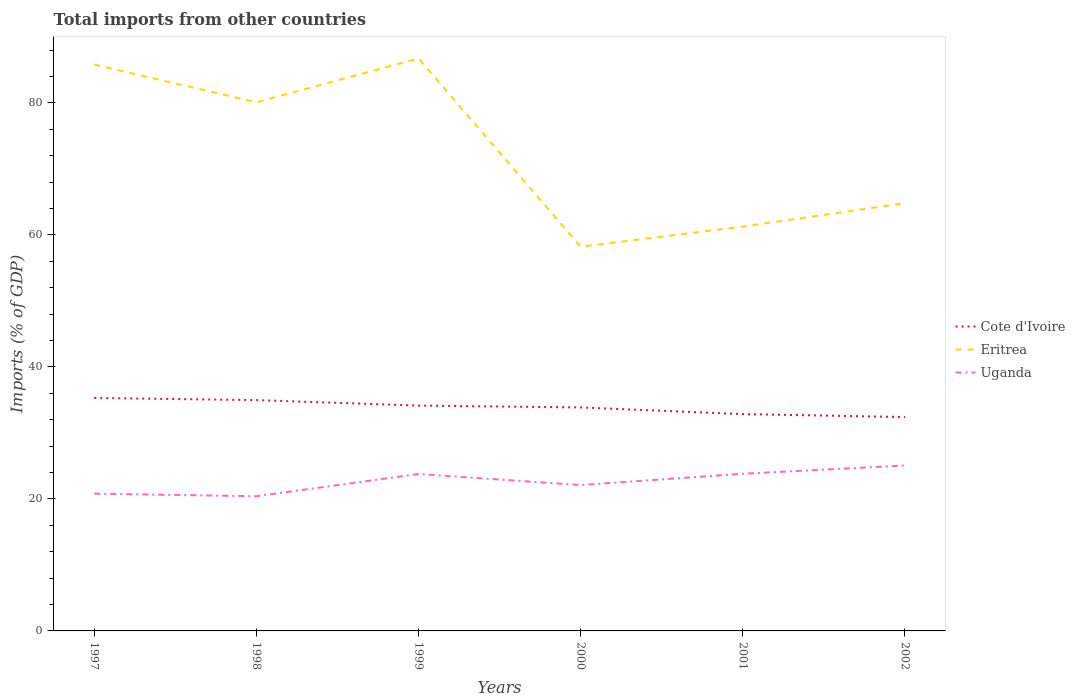How many different coloured lines are there?
Your answer should be compact. 3. Does the line corresponding to Eritrea intersect with the line corresponding to Uganda?
Ensure brevity in your answer.  No. Across all years, what is the maximum total imports in Uganda?
Ensure brevity in your answer.  20.4. In which year was the total imports in Cote d'Ivoire maximum?
Your response must be concise. 2002. What is the total total imports in Uganda in the graph?
Offer a very short reply. -1.29. What is the difference between the highest and the second highest total imports in Eritrea?
Provide a succinct answer. 28.51. What is the difference between the highest and the lowest total imports in Uganda?
Provide a short and direct response. 3. What is the difference between two consecutive major ticks on the Y-axis?
Keep it short and to the point. 20. Does the graph contain any zero values?
Make the answer very short. No. Does the graph contain grids?
Provide a short and direct response. No. Where does the legend appear in the graph?
Offer a terse response. Center right. How are the legend labels stacked?
Keep it short and to the point. Vertical. What is the title of the graph?
Provide a succinct answer. Total imports from other countries. What is the label or title of the X-axis?
Keep it short and to the point. Years. What is the label or title of the Y-axis?
Your answer should be very brief. Imports (% of GDP). What is the Imports (% of GDP) in Cote d'Ivoire in 1997?
Your answer should be very brief. 35.29. What is the Imports (% of GDP) in Eritrea in 1997?
Provide a short and direct response. 85.8. What is the Imports (% of GDP) in Uganda in 1997?
Give a very brief answer. 20.8. What is the Imports (% of GDP) of Cote d'Ivoire in 1998?
Offer a terse response. 34.97. What is the Imports (% of GDP) in Eritrea in 1998?
Ensure brevity in your answer.  80.09. What is the Imports (% of GDP) in Uganda in 1998?
Your answer should be compact. 20.4. What is the Imports (% of GDP) of Cote d'Ivoire in 1999?
Make the answer very short. 34.14. What is the Imports (% of GDP) of Eritrea in 1999?
Offer a very short reply. 86.72. What is the Imports (% of GDP) of Uganda in 1999?
Your answer should be very brief. 23.77. What is the Imports (% of GDP) in Cote d'Ivoire in 2000?
Your response must be concise. 33.86. What is the Imports (% of GDP) in Eritrea in 2000?
Your response must be concise. 58.21. What is the Imports (% of GDP) of Uganda in 2000?
Ensure brevity in your answer.  22.1. What is the Imports (% of GDP) of Cote d'Ivoire in 2001?
Ensure brevity in your answer.  32.85. What is the Imports (% of GDP) in Eritrea in 2001?
Provide a short and direct response. 61.26. What is the Imports (% of GDP) of Uganda in 2001?
Ensure brevity in your answer.  23.81. What is the Imports (% of GDP) of Cote d'Ivoire in 2002?
Offer a very short reply. 32.4. What is the Imports (% of GDP) of Eritrea in 2002?
Provide a succinct answer. 64.81. What is the Imports (% of GDP) of Uganda in 2002?
Give a very brief answer. 25.06. Across all years, what is the maximum Imports (% of GDP) in Cote d'Ivoire?
Give a very brief answer. 35.29. Across all years, what is the maximum Imports (% of GDP) of Eritrea?
Your answer should be very brief. 86.72. Across all years, what is the maximum Imports (% of GDP) in Uganda?
Your answer should be very brief. 25.06. Across all years, what is the minimum Imports (% of GDP) of Cote d'Ivoire?
Offer a very short reply. 32.4. Across all years, what is the minimum Imports (% of GDP) of Eritrea?
Your answer should be very brief. 58.21. Across all years, what is the minimum Imports (% of GDP) in Uganda?
Offer a terse response. 20.4. What is the total Imports (% of GDP) in Cote d'Ivoire in the graph?
Your answer should be very brief. 203.51. What is the total Imports (% of GDP) in Eritrea in the graph?
Keep it short and to the point. 436.89. What is the total Imports (% of GDP) of Uganda in the graph?
Give a very brief answer. 135.95. What is the difference between the Imports (% of GDP) in Cote d'Ivoire in 1997 and that in 1998?
Provide a succinct answer. 0.32. What is the difference between the Imports (% of GDP) of Eritrea in 1997 and that in 1998?
Your answer should be compact. 5.71. What is the difference between the Imports (% of GDP) of Uganda in 1997 and that in 1998?
Provide a short and direct response. 0.39. What is the difference between the Imports (% of GDP) in Cote d'Ivoire in 1997 and that in 1999?
Offer a terse response. 1.15. What is the difference between the Imports (% of GDP) in Eritrea in 1997 and that in 1999?
Ensure brevity in your answer.  -0.92. What is the difference between the Imports (% of GDP) in Uganda in 1997 and that in 1999?
Give a very brief answer. -2.97. What is the difference between the Imports (% of GDP) of Cote d'Ivoire in 1997 and that in 2000?
Your answer should be compact. 1.44. What is the difference between the Imports (% of GDP) in Eritrea in 1997 and that in 2000?
Your response must be concise. 27.59. What is the difference between the Imports (% of GDP) of Uganda in 1997 and that in 2000?
Your answer should be compact. -1.3. What is the difference between the Imports (% of GDP) in Cote d'Ivoire in 1997 and that in 2001?
Offer a terse response. 2.44. What is the difference between the Imports (% of GDP) in Eritrea in 1997 and that in 2001?
Keep it short and to the point. 24.54. What is the difference between the Imports (% of GDP) of Uganda in 1997 and that in 2001?
Your answer should be compact. -3.01. What is the difference between the Imports (% of GDP) of Cote d'Ivoire in 1997 and that in 2002?
Offer a terse response. 2.89. What is the difference between the Imports (% of GDP) of Eritrea in 1997 and that in 2002?
Offer a very short reply. 20.99. What is the difference between the Imports (% of GDP) in Uganda in 1997 and that in 2002?
Provide a succinct answer. -4.27. What is the difference between the Imports (% of GDP) of Cote d'Ivoire in 1998 and that in 1999?
Provide a short and direct response. 0.83. What is the difference between the Imports (% of GDP) of Eritrea in 1998 and that in 1999?
Offer a very short reply. -6.63. What is the difference between the Imports (% of GDP) of Uganda in 1998 and that in 1999?
Offer a very short reply. -3.37. What is the difference between the Imports (% of GDP) of Cote d'Ivoire in 1998 and that in 2000?
Provide a short and direct response. 1.11. What is the difference between the Imports (% of GDP) of Eritrea in 1998 and that in 2000?
Give a very brief answer. 21.88. What is the difference between the Imports (% of GDP) of Uganda in 1998 and that in 2000?
Offer a terse response. -1.69. What is the difference between the Imports (% of GDP) in Cote d'Ivoire in 1998 and that in 2001?
Your response must be concise. 2.12. What is the difference between the Imports (% of GDP) in Eritrea in 1998 and that in 2001?
Give a very brief answer. 18.84. What is the difference between the Imports (% of GDP) of Uganda in 1998 and that in 2001?
Provide a short and direct response. -3.41. What is the difference between the Imports (% of GDP) in Cote d'Ivoire in 1998 and that in 2002?
Offer a very short reply. 2.57. What is the difference between the Imports (% of GDP) in Eritrea in 1998 and that in 2002?
Offer a terse response. 15.28. What is the difference between the Imports (% of GDP) in Uganda in 1998 and that in 2002?
Your response must be concise. -4.66. What is the difference between the Imports (% of GDP) of Cote d'Ivoire in 1999 and that in 2000?
Offer a terse response. 0.28. What is the difference between the Imports (% of GDP) of Eritrea in 1999 and that in 2000?
Provide a succinct answer. 28.51. What is the difference between the Imports (% of GDP) in Uganda in 1999 and that in 2000?
Ensure brevity in your answer.  1.68. What is the difference between the Imports (% of GDP) in Cote d'Ivoire in 1999 and that in 2001?
Your answer should be compact. 1.29. What is the difference between the Imports (% of GDP) of Eritrea in 1999 and that in 2001?
Offer a very short reply. 25.47. What is the difference between the Imports (% of GDP) in Uganda in 1999 and that in 2001?
Offer a very short reply. -0.04. What is the difference between the Imports (% of GDP) of Cote d'Ivoire in 1999 and that in 2002?
Offer a terse response. 1.74. What is the difference between the Imports (% of GDP) of Eritrea in 1999 and that in 2002?
Your response must be concise. 21.92. What is the difference between the Imports (% of GDP) of Uganda in 1999 and that in 2002?
Offer a very short reply. -1.29. What is the difference between the Imports (% of GDP) of Eritrea in 2000 and that in 2001?
Provide a succinct answer. -3.04. What is the difference between the Imports (% of GDP) in Uganda in 2000 and that in 2001?
Ensure brevity in your answer.  -1.71. What is the difference between the Imports (% of GDP) in Cote d'Ivoire in 2000 and that in 2002?
Provide a succinct answer. 1.46. What is the difference between the Imports (% of GDP) in Eritrea in 2000 and that in 2002?
Offer a terse response. -6.6. What is the difference between the Imports (% of GDP) in Uganda in 2000 and that in 2002?
Ensure brevity in your answer.  -2.97. What is the difference between the Imports (% of GDP) of Cote d'Ivoire in 2001 and that in 2002?
Your answer should be compact. 0.45. What is the difference between the Imports (% of GDP) in Eritrea in 2001 and that in 2002?
Your response must be concise. -3.55. What is the difference between the Imports (% of GDP) in Uganda in 2001 and that in 2002?
Make the answer very short. -1.25. What is the difference between the Imports (% of GDP) in Cote d'Ivoire in 1997 and the Imports (% of GDP) in Eritrea in 1998?
Keep it short and to the point. -44.8. What is the difference between the Imports (% of GDP) in Cote d'Ivoire in 1997 and the Imports (% of GDP) in Uganda in 1998?
Make the answer very short. 14.89. What is the difference between the Imports (% of GDP) of Eritrea in 1997 and the Imports (% of GDP) of Uganda in 1998?
Your answer should be very brief. 65.4. What is the difference between the Imports (% of GDP) of Cote d'Ivoire in 1997 and the Imports (% of GDP) of Eritrea in 1999?
Provide a short and direct response. -51.43. What is the difference between the Imports (% of GDP) in Cote d'Ivoire in 1997 and the Imports (% of GDP) in Uganda in 1999?
Ensure brevity in your answer.  11.52. What is the difference between the Imports (% of GDP) in Eritrea in 1997 and the Imports (% of GDP) in Uganda in 1999?
Ensure brevity in your answer.  62.03. What is the difference between the Imports (% of GDP) of Cote d'Ivoire in 1997 and the Imports (% of GDP) of Eritrea in 2000?
Offer a terse response. -22.92. What is the difference between the Imports (% of GDP) of Cote d'Ivoire in 1997 and the Imports (% of GDP) of Uganda in 2000?
Your response must be concise. 13.19. What is the difference between the Imports (% of GDP) of Eritrea in 1997 and the Imports (% of GDP) of Uganda in 2000?
Ensure brevity in your answer.  63.7. What is the difference between the Imports (% of GDP) of Cote d'Ivoire in 1997 and the Imports (% of GDP) of Eritrea in 2001?
Your response must be concise. -25.96. What is the difference between the Imports (% of GDP) in Cote d'Ivoire in 1997 and the Imports (% of GDP) in Uganda in 2001?
Offer a very short reply. 11.48. What is the difference between the Imports (% of GDP) in Eritrea in 1997 and the Imports (% of GDP) in Uganda in 2001?
Make the answer very short. 61.99. What is the difference between the Imports (% of GDP) in Cote d'Ivoire in 1997 and the Imports (% of GDP) in Eritrea in 2002?
Give a very brief answer. -29.52. What is the difference between the Imports (% of GDP) in Cote d'Ivoire in 1997 and the Imports (% of GDP) in Uganda in 2002?
Offer a very short reply. 10.23. What is the difference between the Imports (% of GDP) in Eritrea in 1997 and the Imports (% of GDP) in Uganda in 2002?
Your answer should be compact. 60.74. What is the difference between the Imports (% of GDP) of Cote d'Ivoire in 1998 and the Imports (% of GDP) of Eritrea in 1999?
Make the answer very short. -51.75. What is the difference between the Imports (% of GDP) in Cote d'Ivoire in 1998 and the Imports (% of GDP) in Uganda in 1999?
Make the answer very short. 11.2. What is the difference between the Imports (% of GDP) in Eritrea in 1998 and the Imports (% of GDP) in Uganda in 1999?
Make the answer very short. 56.32. What is the difference between the Imports (% of GDP) in Cote d'Ivoire in 1998 and the Imports (% of GDP) in Eritrea in 2000?
Offer a terse response. -23.24. What is the difference between the Imports (% of GDP) in Cote d'Ivoire in 1998 and the Imports (% of GDP) in Uganda in 2000?
Ensure brevity in your answer.  12.87. What is the difference between the Imports (% of GDP) in Eritrea in 1998 and the Imports (% of GDP) in Uganda in 2000?
Provide a succinct answer. 58. What is the difference between the Imports (% of GDP) in Cote d'Ivoire in 1998 and the Imports (% of GDP) in Eritrea in 2001?
Keep it short and to the point. -26.29. What is the difference between the Imports (% of GDP) in Cote d'Ivoire in 1998 and the Imports (% of GDP) in Uganda in 2001?
Ensure brevity in your answer.  11.16. What is the difference between the Imports (% of GDP) of Eritrea in 1998 and the Imports (% of GDP) of Uganda in 2001?
Your answer should be compact. 56.28. What is the difference between the Imports (% of GDP) of Cote d'Ivoire in 1998 and the Imports (% of GDP) of Eritrea in 2002?
Your answer should be compact. -29.84. What is the difference between the Imports (% of GDP) in Cote d'Ivoire in 1998 and the Imports (% of GDP) in Uganda in 2002?
Keep it short and to the point. 9.91. What is the difference between the Imports (% of GDP) in Eritrea in 1998 and the Imports (% of GDP) in Uganda in 2002?
Keep it short and to the point. 55.03. What is the difference between the Imports (% of GDP) in Cote d'Ivoire in 1999 and the Imports (% of GDP) in Eritrea in 2000?
Your answer should be compact. -24.07. What is the difference between the Imports (% of GDP) of Cote d'Ivoire in 1999 and the Imports (% of GDP) of Uganda in 2000?
Ensure brevity in your answer.  12.04. What is the difference between the Imports (% of GDP) of Eritrea in 1999 and the Imports (% of GDP) of Uganda in 2000?
Your response must be concise. 64.63. What is the difference between the Imports (% of GDP) of Cote d'Ivoire in 1999 and the Imports (% of GDP) of Eritrea in 2001?
Ensure brevity in your answer.  -27.12. What is the difference between the Imports (% of GDP) in Cote d'Ivoire in 1999 and the Imports (% of GDP) in Uganda in 2001?
Your answer should be very brief. 10.33. What is the difference between the Imports (% of GDP) of Eritrea in 1999 and the Imports (% of GDP) of Uganda in 2001?
Offer a very short reply. 62.91. What is the difference between the Imports (% of GDP) in Cote d'Ivoire in 1999 and the Imports (% of GDP) in Eritrea in 2002?
Your answer should be very brief. -30.67. What is the difference between the Imports (% of GDP) of Cote d'Ivoire in 1999 and the Imports (% of GDP) of Uganda in 2002?
Provide a succinct answer. 9.07. What is the difference between the Imports (% of GDP) of Eritrea in 1999 and the Imports (% of GDP) of Uganda in 2002?
Provide a succinct answer. 61.66. What is the difference between the Imports (% of GDP) of Cote d'Ivoire in 2000 and the Imports (% of GDP) of Eritrea in 2001?
Provide a succinct answer. -27.4. What is the difference between the Imports (% of GDP) in Cote d'Ivoire in 2000 and the Imports (% of GDP) in Uganda in 2001?
Offer a terse response. 10.04. What is the difference between the Imports (% of GDP) in Eritrea in 2000 and the Imports (% of GDP) in Uganda in 2001?
Your answer should be compact. 34.4. What is the difference between the Imports (% of GDP) in Cote d'Ivoire in 2000 and the Imports (% of GDP) in Eritrea in 2002?
Your response must be concise. -30.95. What is the difference between the Imports (% of GDP) of Cote d'Ivoire in 2000 and the Imports (% of GDP) of Uganda in 2002?
Ensure brevity in your answer.  8.79. What is the difference between the Imports (% of GDP) of Eritrea in 2000 and the Imports (% of GDP) of Uganda in 2002?
Make the answer very short. 33.15. What is the difference between the Imports (% of GDP) of Cote d'Ivoire in 2001 and the Imports (% of GDP) of Eritrea in 2002?
Your response must be concise. -31.96. What is the difference between the Imports (% of GDP) of Cote d'Ivoire in 2001 and the Imports (% of GDP) of Uganda in 2002?
Provide a short and direct response. 7.79. What is the difference between the Imports (% of GDP) of Eritrea in 2001 and the Imports (% of GDP) of Uganda in 2002?
Your answer should be compact. 36.19. What is the average Imports (% of GDP) in Cote d'Ivoire per year?
Make the answer very short. 33.92. What is the average Imports (% of GDP) of Eritrea per year?
Your response must be concise. 72.82. What is the average Imports (% of GDP) in Uganda per year?
Give a very brief answer. 22.66. In the year 1997, what is the difference between the Imports (% of GDP) in Cote d'Ivoire and Imports (% of GDP) in Eritrea?
Your response must be concise. -50.51. In the year 1997, what is the difference between the Imports (% of GDP) of Cote d'Ivoire and Imports (% of GDP) of Uganda?
Offer a terse response. 14.49. In the year 1997, what is the difference between the Imports (% of GDP) in Eritrea and Imports (% of GDP) in Uganda?
Ensure brevity in your answer.  65. In the year 1998, what is the difference between the Imports (% of GDP) of Cote d'Ivoire and Imports (% of GDP) of Eritrea?
Keep it short and to the point. -45.12. In the year 1998, what is the difference between the Imports (% of GDP) of Cote d'Ivoire and Imports (% of GDP) of Uganda?
Provide a succinct answer. 14.57. In the year 1998, what is the difference between the Imports (% of GDP) of Eritrea and Imports (% of GDP) of Uganda?
Your response must be concise. 59.69. In the year 1999, what is the difference between the Imports (% of GDP) in Cote d'Ivoire and Imports (% of GDP) in Eritrea?
Make the answer very short. -52.59. In the year 1999, what is the difference between the Imports (% of GDP) of Cote d'Ivoire and Imports (% of GDP) of Uganda?
Make the answer very short. 10.36. In the year 1999, what is the difference between the Imports (% of GDP) of Eritrea and Imports (% of GDP) of Uganda?
Ensure brevity in your answer.  62.95. In the year 2000, what is the difference between the Imports (% of GDP) in Cote d'Ivoire and Imports (% of GDP) in Eritrea?
Keep it short and to the point. -24.35. In the year 2000, what is the difference between the Imports (% of GDP) of Cote d'Ivoire and Imports (% of GDP) of Uganda?
Provide a short and direct response. 11.76. In the year 2000, what is the difference between the Imports (% of GDP) in Eritrea and Imports (% of GDP) in Uganda?
Give a very brief answer. 36.11. In the year 2001, what is the difference between the Imports (% of GDP) in Cote d'Ivoire and Imports (% of GDP) in Eritrea?
Your answer should be compact. -28.41. In the year 2001, what is the difference between the Imports (% of GDP) in Cote d'Ivoire and Imports (% of GDP) in Uganda?
Offer a terse response. 9.04. In the year 2001, what is the difference between the Imports (% of GDP) in Eritrea and Imports (% of GDP) in Uganda?
Your answer should be compact. 37.44. In the year 2002, what is the difference between the Imports (% of GDP) of Cote d'Ivoire and Imports (% of GDP) of Eritrea?
Offer a terse response. -32.41. In the year 2002, what is the difference between the Imports (% of GDP) of Cote d'Ivoire and Imports (% of GDP) of Uganda?
Make the answer very short. 7.34. In the year 2002, what is the difference between the Imports (% of GDP) in Eritrea and Imports (% of GDP) in Uganda?
Ensure brevity in your answer.  39.74. What is the ratio of the Imports (% of GDP) of Cote d'Ivoire in 1997 to that in 1998?
Your response must be concise. 1.01. What is the ratio of the Imports (% of GDP) of Eritrea in 1997 to that in 1998?
Offer a terse response. 1.07. What is the ratio of the Imports (% of GDP) of Uganda in 1997 to that in 1998?
Provide a short and direct response. 1.02. What is the ratio of the Imports (% of GDP) of Cote d'Ivoire in 1997 to that in 1999?
Ensure brevity in your answer.  1.03. What is the ratio of the Imports (% of GDP) of Eritrea in 1997 to that in 1999?
Keep it short and to the point. 0.99. What is the ratio of the Imports (% of GDP) in Uganda in 1997 to that in 1999?
Ensure brevity in your answer.  0.87. What is the ratio of the Imports (% of GDP) in Cote d'Ivoire in 1997 to that in 2000?
Your response must be concise. 1.04. What is the ratio of the Imports (% of GDP) in Eritrea in 1997 to that in 2000?
Make the answer very short. 1.47. What is the ratio of the Imports (% of GDP) in Uganda in 1997 to that in 2000?
Keep it short and to the point. 0.94. What is the ratio of the Imports (% of GDP) in Cote d'Ivoire in 1997 to that in 2001?
Your answer should be compact. 1.07. What is the ratio of the Imports (% of GDP) of Eritrea in 1997 to that in 2001?
Provide a short and direct response. 1.4. What is the ratio of the Imports (% of GDP) of Uganda in 1997 to that in 2001?
Make the answer very short. 0.87. What is the ratio of the Imports (% of GDP) of Cote d'Ivoire in 1997 to that in 2002?
Your answer should be very brief. 1.09. What is the ratio of the Imports (% of GDP) of Eritrea in 1997 to that in 2002?
Give a very brief answer. 1.32. What is the ratio of the Imports (% of GDP) of Uganda in 1997 to that in 2002?
Provide a succinct answer. 0.83. What is the ratio of the Imports (% of GDP) in Cote d'Ivoire in 1998 to that in 1999?
Your answer should be compact. 1.02. What is the ratio of the Imports (% of GDP) in Eritrea in 1998 to that in 1999?
Give a very brief answer. 0.92. What is the ratio of the Imports (% of GDP) of Uganda in 1998 to that in 1999?
Ensure brevity in your answer.  0.86. What is the ratio of the Imports (% of GDP) in Cote d'Ivoire in 1998 to that in 2000?
Keep it short and to the point. 1.03. What is the ratio of the Imports (% of GDP) of Eritrea in 1998 to that in 2000?
Provide a succinct answer. 1.38. What is the ratio of the Imports (% of GDP) of Uganda in 1998 to that in 2000?
Offer a very short reply. 0.92. What is the ratio of the Imports (% of GDP) of Cote d'Ivoire in 1998 to that in 2001?
Your answer should be very brief. 1.06. What is the ratio of the Imports (% of GDP) of Eritrea in 1998 to that in 2001?
Provide a succinct answer. 1.31. What is the ratio of the Imports (% of GDP) in Uganda in 1998 to that in 2001?
Keep it short and to the point. 0.86. What is the ratio of the Imports (% of GDP) in Cote d'Ivoire in 1998 to that in 2002?
Provide a succinct answer. 1.08. What is the ratio of the Imports (% of GDP) of Eritrea in 1998 to that in 2002?
Provide a succinct answer. 1.24. What is the ratio of the Imports (% of GDP) of Uganda in 1998 to that in 2002?
Ensure brevity in your answer.  0.81. What is the ratio of the Imports (% of GDP) of Cote d'Ivoire in 1999 to that in 2000?
Make the answer very short. 1.01. What is the ratio of the Imports (% of GDP) of Eritrea in 1999 to that in 2000?
Keep it short and to the point. 1.49. What is the ratio of the Imports (% of GDP) of Uganda in 1999 to that in 2000?
Provide a short and direct response. 1.08. What is the ratio of the Imports (% of GDP) in Cote d'Ivoire in 1999 to that in 2001?
Give a very brief answer. 1.04. What is the ratio of the Imports (% of GDP) of Eritrea in 1999 to that in 2001?
Offer a terse response. 1.42. What is the ratio of the Imports (% of GDP) in Uganda in 1999 to that in 2001?
Offer a very short reply. 1. What is the ratio of the Imports (% of GDP) of Cote d'Ivoire in 1999 to that in 2002?
Make the answer very short. 1.05. What is the ratio of the Imports (% of GDP) in Eritrea in 1999 to that in 2002?
Offer a terse response. 1.34. What is the ratio of the Imports (% of GDP) in Uganda in 1999 to that in 2002?
Offer a very short reply. 0.95. What is the ratio of the Imports (% of GDP) of Cote d'Ivoire in 2000 to that in 2001?
Your answer should be very brief. 1.03. What is the ratio of the Imports (% of GDP) in Eritrea in 2000 to that in 2001?
Provide a succinct answer. 0.95. What is the ratio of the Imports (% of GDP) in Uganda in 2000 to that in 2001?
Make the answer very short. 0.93. What is the ratio of the Imports (% of GDP) of Cote d'Ivoire in 2000 to that in 2002?
Give a very brief answer. 1.04. What is the ratio of the Imports (% of GDP) in Eritrea in 2000 to that in 2002?
Offer a very short reply. 0.9. What is the ratio of the Imports (% of GDP) of Uganda in 2000 to that in 2002?
Make the answer very short. 0.88. What is the ratio of the Imports (% of GDP) of Cote d'Ivoire in 2001 to that in 2002?
Make the answer very short. 1.01. What is the ratio of the Imports (% of GDP) of Eritrea in 2001 to that in 2002?
Provide a short and direct response. 0.95. What is the ratio of the Imports (% of GDP) in Uganda in 2001 to that in 2002?
Keep it short and to the point. 0.95. What is the difference between the highest and the second highest Imports (% of GDP) of Cote d'Ivoire?
Offer a terse response. 0.32. What is the difference between the highest and the second highest Imports (% of GDP) of Eritrea?
Provide a succinct answer. 0.92. What is the difference between the highest and the second highest Imports (% of GDP) in Uganda?
Make the answer very short. 1.25. What is the difference between the highest and the lowest Imports (% of GDP) of Cote d'Ivoire?
Make the answer very short. 2.89. What is the difference between the highest and the lowest Imports (% of GDP) of Eritrea?
Offer a very short reply. 28.51. What is the difference between the highest and the lowest Imports (% of GDP) in Uganda?
Provide a short and direct response. 4.66. 